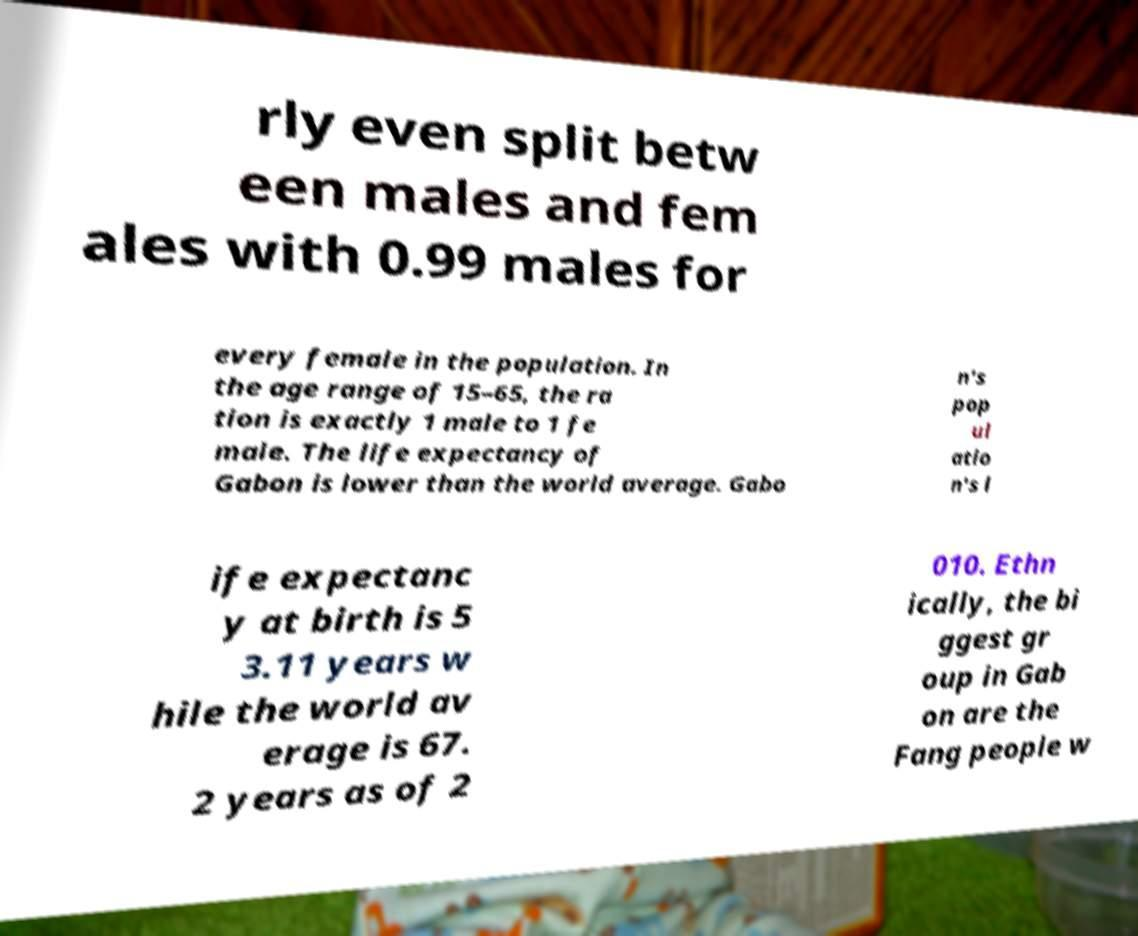Please identify and transcribe the text found in this image. rly even split betw een males and fem ales with 0.99 males for every female in the population. In the age range of 15–65, the ra tion is exactly 1 male to 1 fe male. The life expectancy of Gabon is lower than the world average. Gabo n's pop ul atio n's l ife expectanc y at birth is 5 3.11 years w hile the world av erage is 67. 2 years as of 2 010. Ethn ically, the bi ggest gr oup in Gab on are the Fang people w 